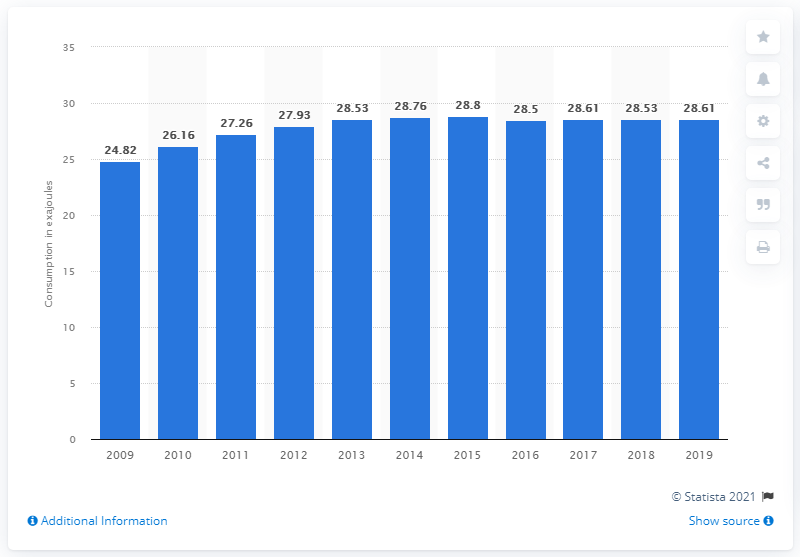Draw attention to some important aspects in this diagram. In 2015, the energy consumption in Central and South America was 28.8 exajoules. 